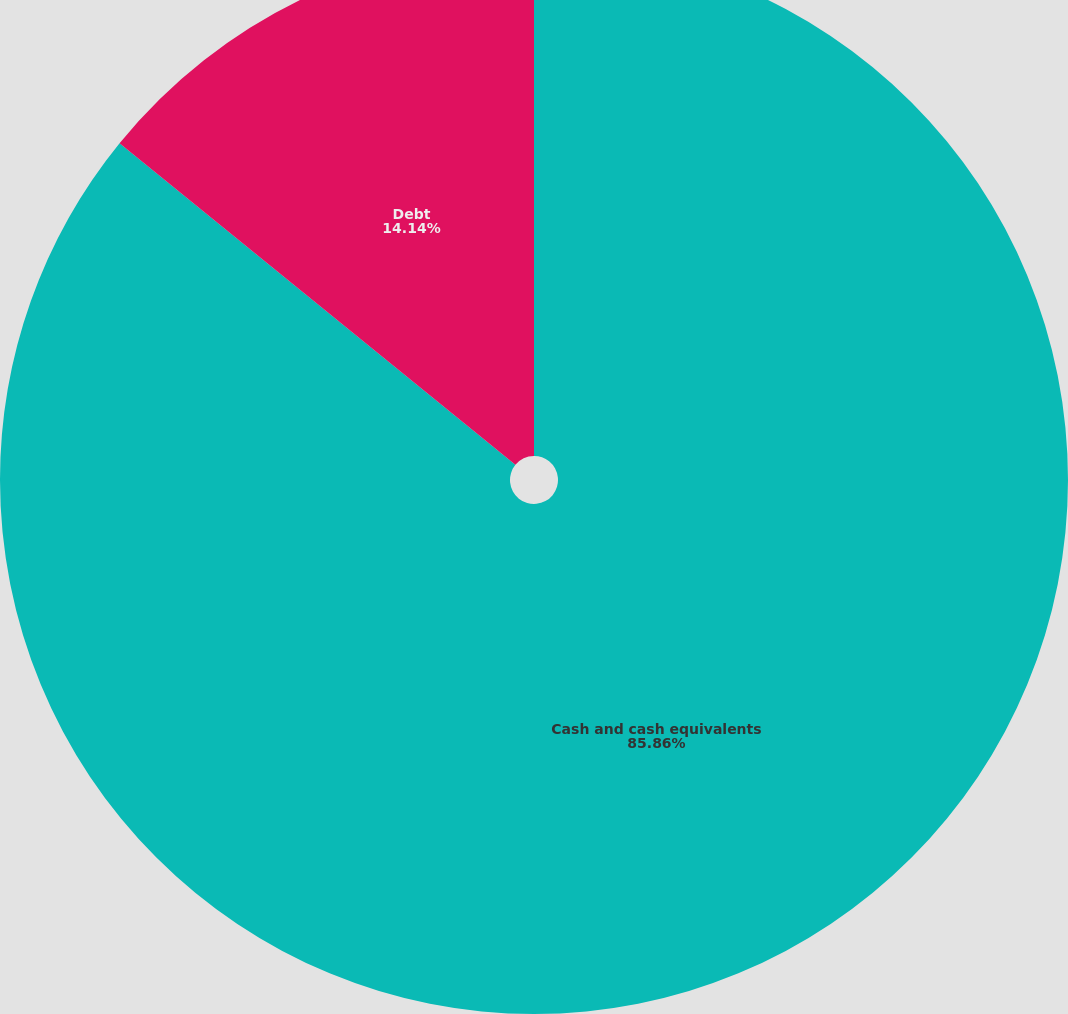Convert chart. <chart><loc_0><loc_0><loc_500><loc_500><pie_chart><fcel>Cash and cash equivalents<fcel>Debt<nl><fcel>85.86%<fcel>14.14%<nl></chart> 